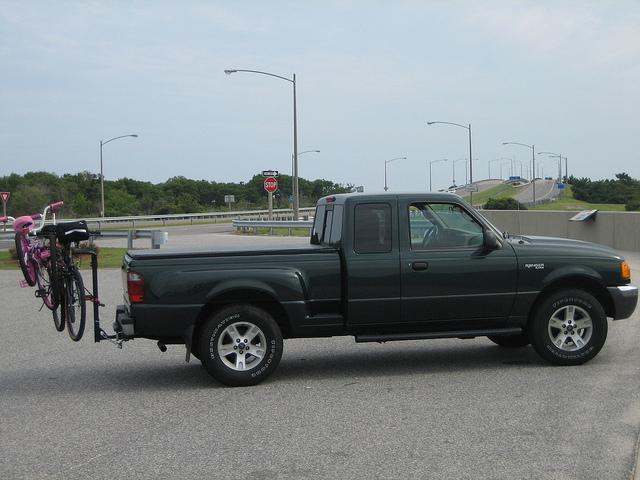How many doors does the truck have?
Give a very brief answer. 2. How many bicycles are there?
Give a very brief answer. 2. How many giraffes are bent down?
Give a very brief answer. 0. 